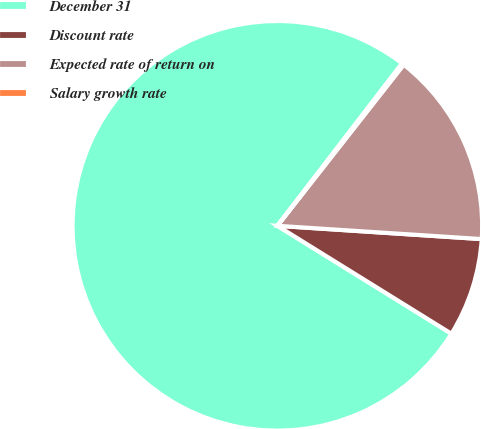<chart> <loc_0><loc_0><loc_500><loc_500><pie_chart><fcel>December 31<fcel>Discount rate<fcel>Expected rate of return on<fcel>Salary growth rate<nl><fcel>76.59%<fcel>7.8%<fcel>15.45%<fcel>0.16%<nl></chart> 